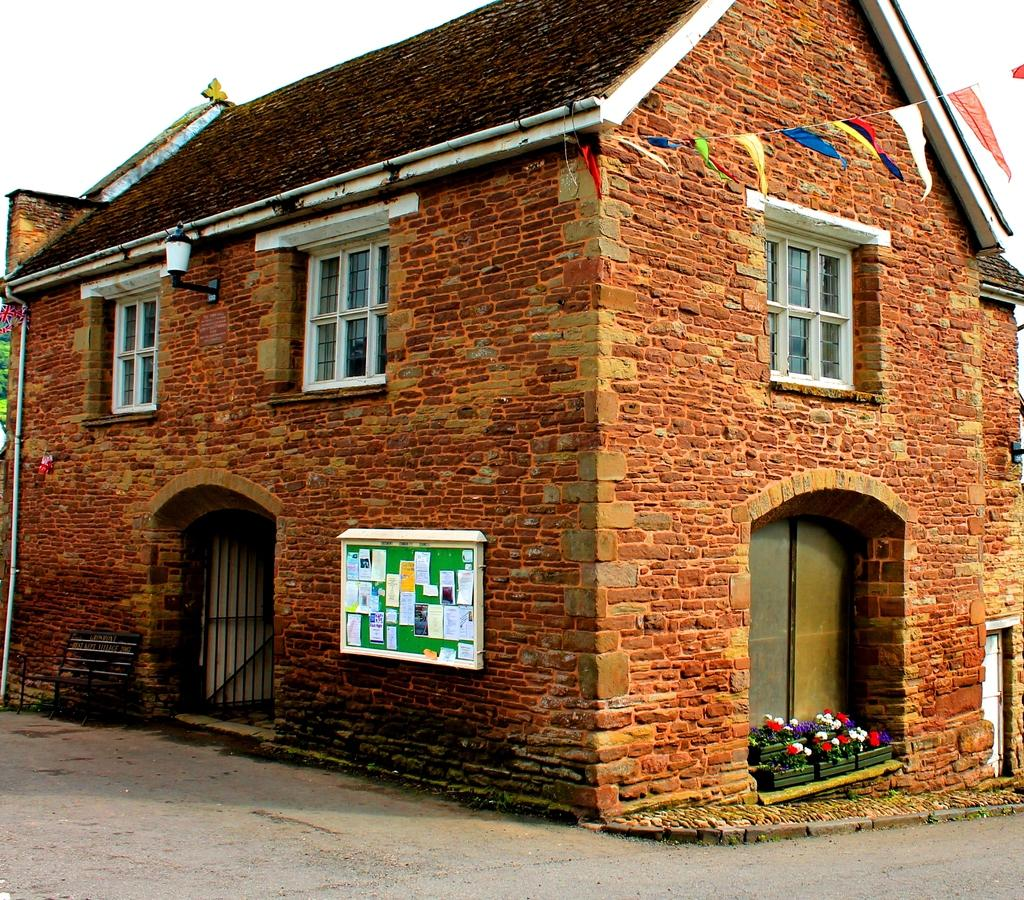What is the main subject in the center of the image? There is a house in the center of the image. What is located at the bottom of the image? There is a road at the bottom of the image. What can be seen at the top of the image? There is sky visible at the top of the image. What feature can be observed on the house? There are windows on the house. What type of celery is being used to create the mist in the image? There is no celery or mist present in the image; it features a house, a road, and sky. 